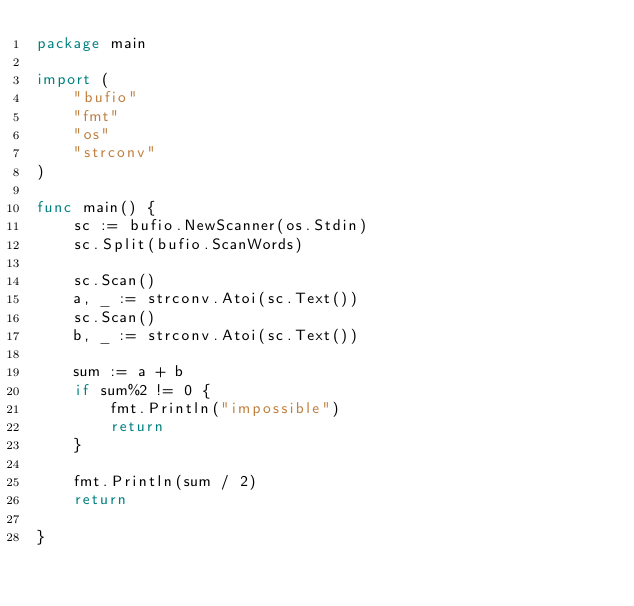<code> <loc_0><loc_0><loc_500><loc_500><_Go_>package main

import (
	"bufio"
	"fmt"
	"os"
	"strconv"
)

func main() {
	sc := bufio.NewScanner(os.Stdin)
	sc.Split(bufio.ScanWords)

	sc.Scan()
	a, _ := strconv.Atoi(sc.Text())
	sc.Scan()
	b, _ := strconv.Atoi(sc.Text())

	sum := a + b
	if sum%2 != 0 {
		fmt.Println("impossible")
		return
	}

	fmt.Println(sum / 2)
	return

}
</code> 